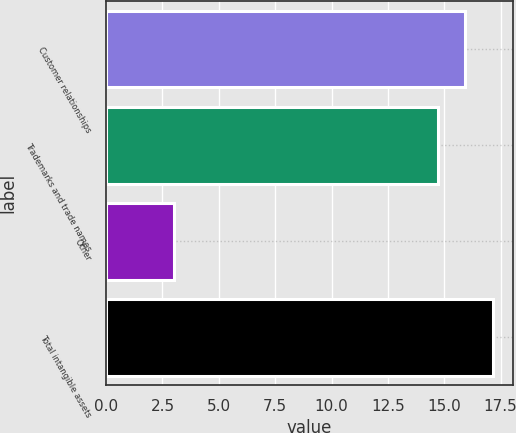Convert chart. <chart><loc_0><loc_0><loc_500><loc_500><bar_chart><fcel>Customer relationships<fcel>Trademarks and trade names<fcel>Other<fcel>Total intangible assets<nl><fcel>15.94<fcel>14.7<fcel>3<fcel>17.18<nl></chart> 